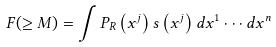<formula> <loc_0><loc_0><loc_500><loc_500>F ( \geq M ) = \int P _ { R } \left ( x ^ { j } \right ) s \left ( x ^ { j } \right ) d x ^ { 1 } \cdot \cdot \cdot d x ^ { n }</formula> 